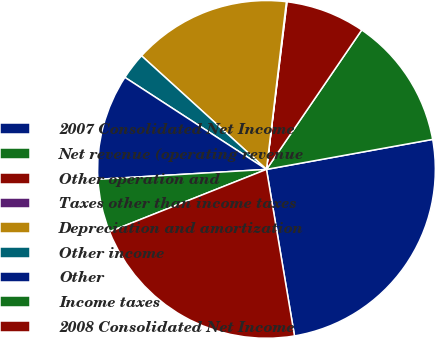<chart> <loc_0><loc_0><loc_500><loc_500><pie_chart><fcel>2007 Consolidated Net Income<fcel>Net revenue (operating revenue<fcel>Other operation and<fcel>Taxes other than income taxes<fcel>Depreciation and amortization<fcel>Other income<fcel>Other<fcel>Income taxes<fcel>2008 Consolidated Net Income<nl><fcel>25.19%<fcel>12.62%<fcel>7.6%<fcel>0.06%<fcel>15.14%<fcel>2.57%<fcel>10.11%<fcel>5.08%<fcel>21.64%<nl></chart> 